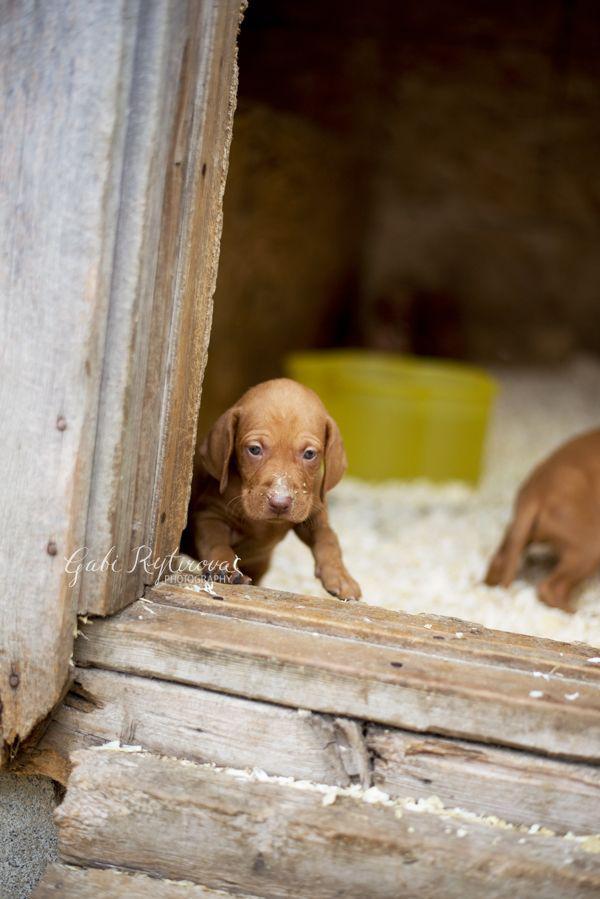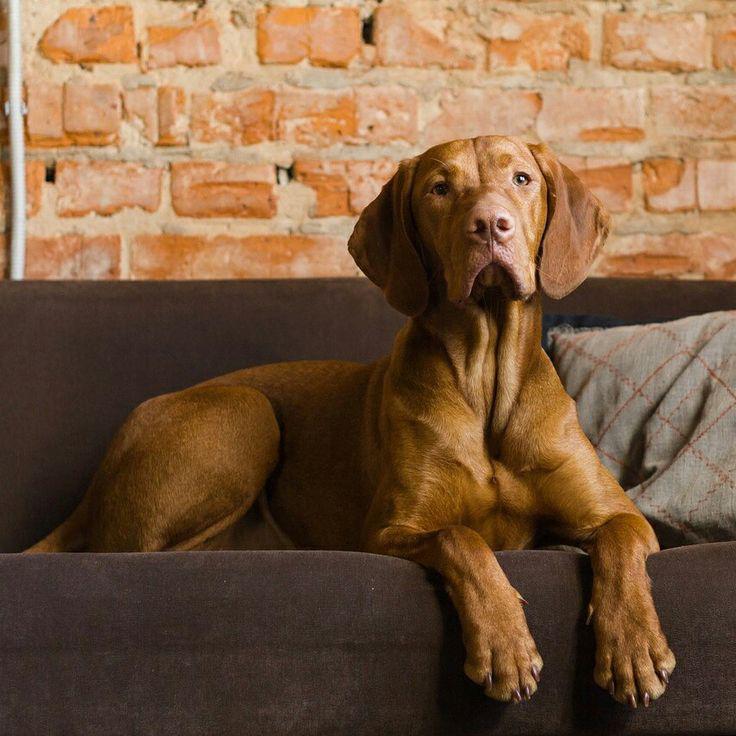The first image is the image on the left, the second image is the image on the right. Assess this claim about the two images: "A dog is laying down inside.". Correct or not? Answer yes or no. Yes. The first image is the image on the left, the second image is the image on the right. For the images displayed, is the sentence "The left image features a puppy peering over a wooden ledge, and the right image includes a reclining adult dog with its head lifted to gaze upward." factually correct? Answer yes or no. Yes. 